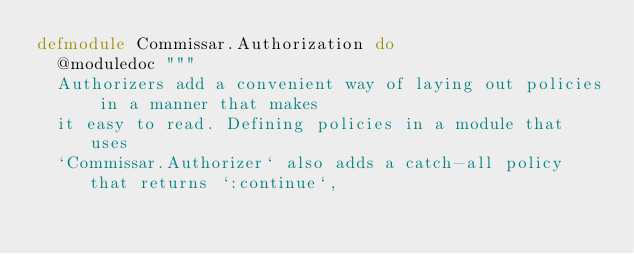<code> <loc_0><loc_0><loc_500><loc_500><_Elixir_>defmodule Commissar.Authorization do
  @moduledoc """
  Authorizers add a convenient way of laying out policies in a manner that makes
  it easy to read. Defining policies in a module that uses
  `Commissar.Authorizer` also adds a catch-all policy that returns `:continue`,</code> 